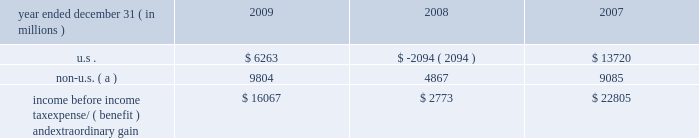Notes to consolidated financial statements jpmorgan chase & co./2009 annual report 236 the table presents the u.s .
And non-u.s .
Components of income before income tax expense/ ( benefit ) and extraordinary gain for the years ended december 31 , 2009 , 2008 and 2007 .
Year ended december 31 , ( in millions ) 2009 2008 2007 .
Non-u.s. ( a ) 9804 4867 9085 income before income tax expense/ ( benefit ) and extraordinary gain $ 16067 $ 2773 $ 22805 ( a ) for purposes of this table , non-u.s .
Income is defined as income generated from operations located outside the u.s .
Note 28 2013 restrictions on cash and inter- company funds transfers the business of jpmorgan chase bank , national association ( 201cjpmorgan chase bank , n.a . 201d ) is subject to examination and regulation by the office of the comptroller of the currency ( 201cocc 201d ) .
The bank is a member of the u.s .
Federal reserve sys- tem , and its deposits are insured by the fdic .
The board of governors of the federal reserve system ( the 201cfed- eral reserve 201d ) requires depository institutions to maintain cash reserves with a federal reserve bank .
The average amount of reserve balances deposited by the firm 2019s bank subsidiaries with various federal reserve banks was approximately $ 821 million and $ 1.6 billion in 2009 and 2008 , respectively .
Restrictions imposed by u.s .
Federal law prohibit jpmorgan chase and certain of its affiliates from borrowing from banking subsidiar- ies unless the loans are secured in specified amounts .
Such secured loans to the firm or to other affiliates are generally limited to 10% ( 10 % ) of the banking subsidiary 2019s total capital , as determined by the risk- based capital guidelines ; the aggregate amount of all such loans is limited to 20% ( 20 % ) of the banking subsidiary 2019s total capital .
The principal sources of jpmorgan chase 2019s income ( on a parent company 2013only basis ) are dividends and interest from jpmorgan chase bank , n.a. , and the other banking and nonbanking subsidi- aries of jpmorgan chase .
In addition to dividend restrictions set forth in statutes and regulations , the federal reserve , the occ and the fdic have authority under the financial institutions supervisory act to prohibit or to limit the payment of dividends by the banking organizations they supervise , including jpmorgan chase and its subsidiaries that are banks or bank holding companies , if , in the banking regulator 2019s opinion , payment of a dividend would consti- tute an unsafe or unsound practice in light of the financial condi- tion of the banking organization .
At january 1 , 2010 and 2009 , jpmorgan chase 2019s banking subsidi- aries could pay , in the aggregate , $ 3.6 billion and $ 17.0 billion , respectively , in dividends to their respective bank holding compa- nies without the prior approval of their relevant banking regulators .
The capacity to pay dividends in 2010 will be supplemented by the banking subsidiaries 2019 earnings during the year .
In compliance with rules and regulations established by u.s .
And non-u.s .
Regulators , as of december 31 , 2009 and 2008 , cash in the amount of $ 24.0 billion and $ 34.8 billion , respectively , and securities with a fair value of $ 10.2 billion and $ 23.4 billion , re- spectively , were segregated in special bank accounts for the benefit of securities and futures brokerage customers .
Note 29 2013 capital the federal reserve establishes capital requirements , including well-capitalized standards for the consolidated financial holding company .
The occ establishes similar capital requirements and standards for the firm 2019s national banks , including jpmorgan chase bank , n.a. , and chase bank usa , n.a .
There are two categories of risk-based capital : tier 1 capital and tier 2 capital .
Tier 1 capital includes common stockholders 2019 equity , qualifying preferred stock and minority interest less goodwill and other adjustments .
Tier 2 capital consists of preferred stock not qualifying as tier 1 , subordinated long-term debt and other instru- ments qualifying as tier 2 , and the aggregate allowance for credit losses up to a certain percentage of risk-weighted assets .
Total regulatory capital is subject to deductions for investments in certain subsidiaries .
Under the risk-based capital guidelines of the federal reserve , jpmorgan chase is required to maintain minimum ratios of tier 1 and total ( tier 1 plus tier 2 ) capital to risk-weighted assets , as well as minimum leverage ratios ( which are defined as tier 1 capital to average adjusted on 2013balance sheet assets ) .
Failure to meet these minimum requirements could cause the federal reserve to take action .
Banking subsidiaries also are subject to these capital requirements by their respective primary regulators .
As of december 31 , 2009 and 2008 , jpmorgan chase and all of its banking sub- sidiaries were well-capitalized and met all capital requirements to which each was subject. .
For the year ended december 312009 what was the percentage of the income before income tax expense/ ( benefit ) and extraordinary gain from the us? 
Computations: (6263 / 16067)
Answer: 0.38981. Notes to consolidated financial statements jpmorgan chase & co./2009 annual report 236 the table presents the u.s .
And non-u.s .
Components of income before income tax expense/ ( benefit ) and extraordinary gain for the years ended december 31 , 2009 , 2008 and 2007 .
Year ended december 31 , ( in millions ) 2009 2008 2007 .
Non-u.s. ( a ) 9804 4867 9085 income before income tax expense/ ( benefit ) and extraordinary gain $ 16067 $ 2773 $ 22805 ( a ) for purposes of this table , non-u.s .
Income is defined as income generated from operations located outside the u.s .
Note 28 2013 restrictions on cash and inter- company funds transfers the business of jpmorgan chase bank , national association ( 201cjpmorgan chase bank , n.a . 201d ) is subject to examination and regulation by the office of the comptroller of the currency ( 201cocc 201d ) .
The bank is a member of the u.s .
Federal reserve sys- tem , and its deposits are insured by the fdic .
The board of governors of the federal reserve system ( the 201cfed- eral reserve 201d ) requires depository institutions to maintain cash reserves with a federal reserve bank .
The average amount of reserve balances deposited by the firm 2019s bank subsidiaries with various federal reserve banks was approximately $ 821 million and $ 1.6 billion in 2009 and 2008 , respectively .
Restrictions imposed by u.s .
Federal law prohibit jpmorgan chase and certain of its affiliates from borrowing from banking subsidiar- ies unless the loans are secured in specified amounts .
Such secured loans to the firm or to other affiliates are generally limited to 10% ( 10 % ) of the banking subsidiary 2019s total capital , as determined by the risk- based capital guidelines ; the aggregate amount of all such loans is limited to 20% ( 20 % ) of the banking subsidiary 2019s total capital .
The principal sources of jpmorgan chase 2019s income ( on a parent company 2013only basis ) are dividends and interest from jpmorgan chase bank , n.a. , and the other banking and nonbanking subsidi- aries of jpmorgan chase .
In addition to dividend restrictions set forth in statutes and regulations , the federal reserve , the occ and the fdic have authority under the financial institutions supervisory act to prohibit or to limit the payment of dividends by the banking organizations they supervise , including jpmorgan chase and its subsidiaries that are banks or bank holding companies , if , in the banking regulator 2019s opinion , payment of a dividend would consti- tute an unsafe or unsound practice in light of the financial condi- tion of the banking organization .
At january 1 , 2010 and 2009 , jpmorgan chase 2019s banking subsidi- aries could pay , in the aggregate , $ 3.6 billion and $ 17.0 billion , respectively , in dividends to their respective bank holding compa- nies without the prior approval of their relevant banking regulators .
The capacity to pay dividends in 2010 will be supplemented by the banking subsidiaries 2019 earnings during the year .
In compliance with rules and regulations established by u.s .
And non-u.s .
Regulators , as of december 31 , 2009 and 2008 , cash in the amount of $ 24.0 billion and $ 34.8 billion , respectively , and securities with a fair value of $ 10.2 billion and $ 23.4 billion , re- spectively , were segregated in special bank accounts for the benefit of securities and futures brokerage customers .
Note 29 2013 capital the federal reserve establishes capital requirements , including well-capitalized standards for the consolidated financial holding company .
The occ establishes similar capital requirements and standards for the firm 2019s national banks , including jpmorgan chase bank , n.a. , and chase bank usa , n.a .
There are two categories of risk-based capital : tier 1 capital and tier 2 capital .
Tier 1 capital includes common stockholders 2019 equity , qualifying preferred stock and minority interest less goodwill and other adjustments .
Tier 2 capital consists of preferred stock not qualifying as tier 1 , subordinated long-term debt and other instru- ments qualifying as tier 2 , and the aggregate allowance for credit losses up to a certain percentage of risk-weighted assets .
Total regulatory capital is subject to deductions for investments in certain subsidiaries .
Under the risk-based capital guidelines of the federal reserve , jpmorgan chase is required to maintain minimum ratios of tier 1 and total ( tier 1 plus tier 2 ) capital to risk-weighted assets , as well as minimum leverage ratios ( which are defined as tier 1 capital to average adjusted on 2013balance sheet assets ) .
Failure to meet these minimum requirements could cause the federal reserve to take action .
Banking subsidiaries also are subject to these capital requirements by their respective primary regulators .
As of december 31 , 2009 and 2008 , jpmorgan chase and all of its banking sub- sidiaries were well-capitalized and met all capital requirements to which each was subject. .
For 2009 , how much of pretax income was from outside the us? 
Computations: (9804 / 16067)
Answer: 0.61019. 